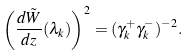<formula> <loc_0><loc_0><loc_500><loc_500>\left ( \frac { d \tilde { W } } { d z } ( \lambda _ { k } ) \right ) ^ { 2 } = ( \gamma _ { k } ^ { + } \gamma _ { k } ^ { - } ) ^ { - 2 } .</formula> 